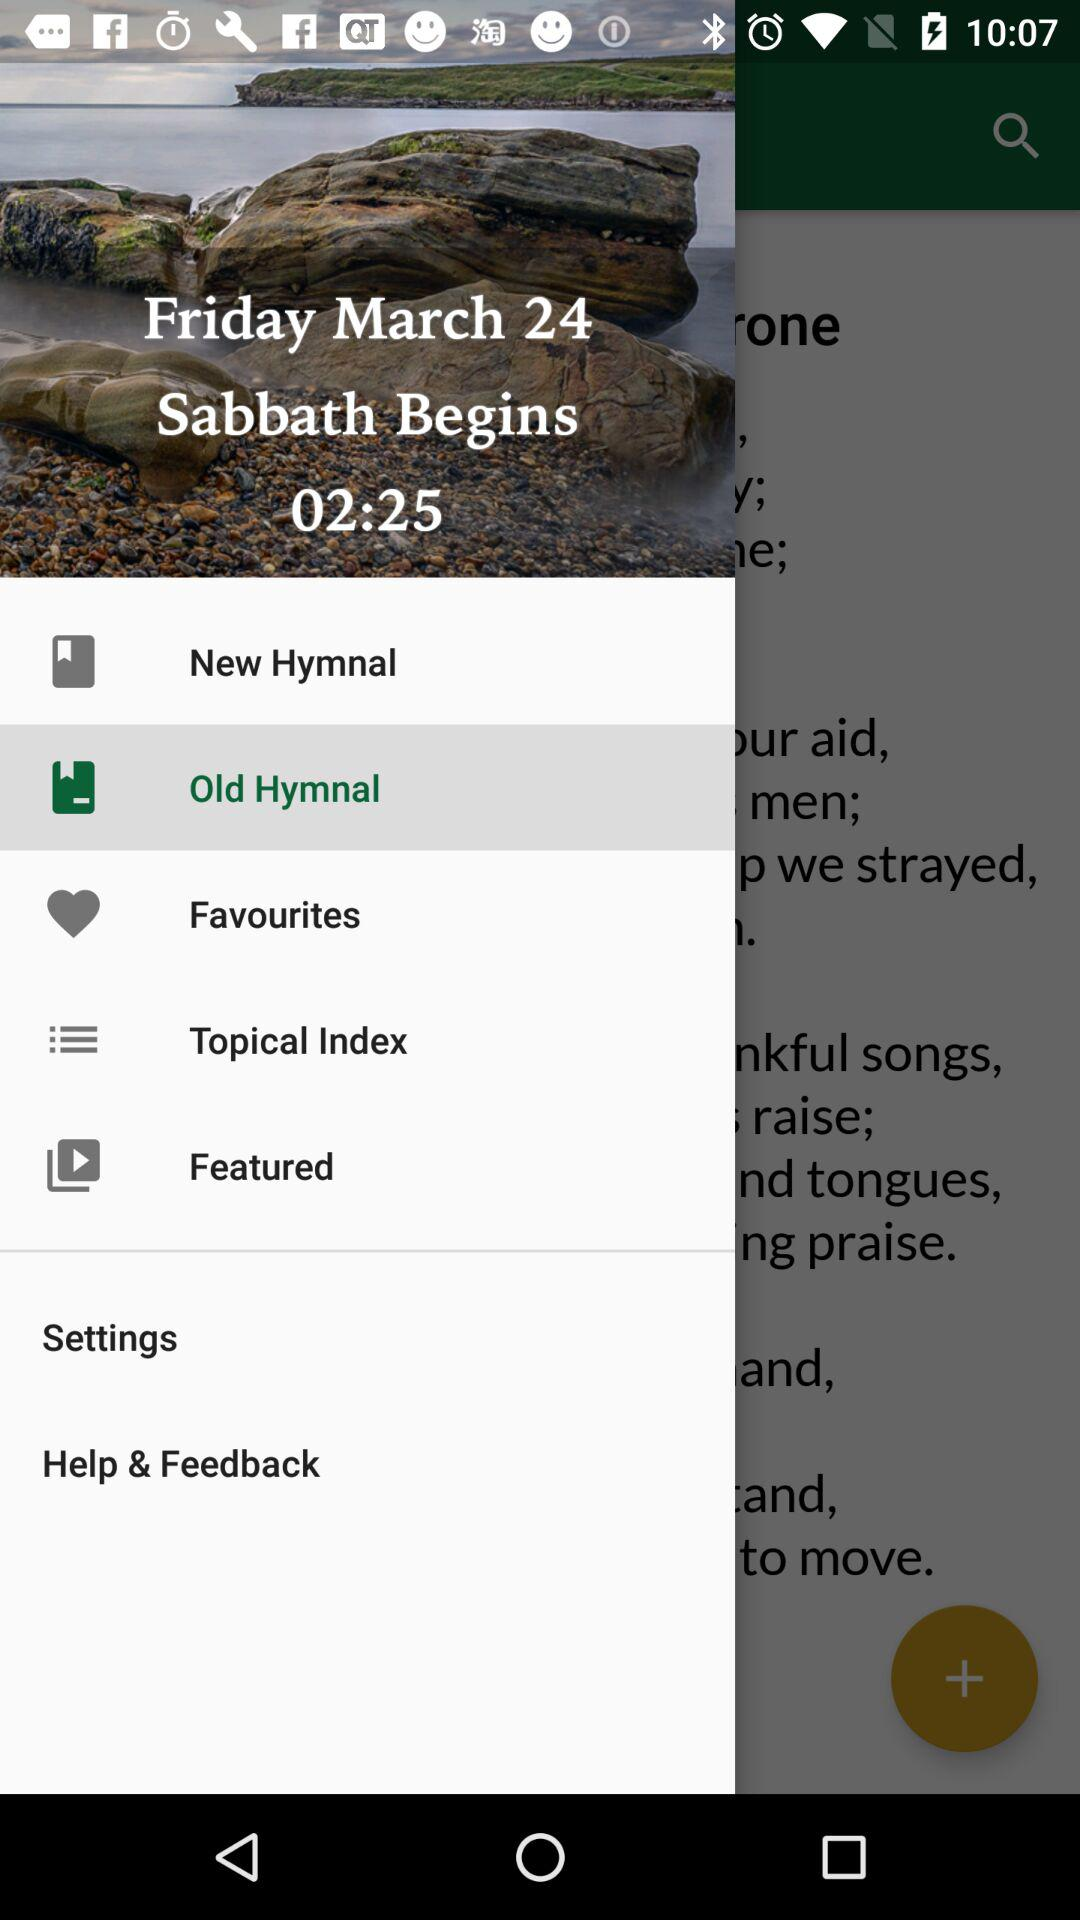Which item is selected? The selected item is "Old Hymnal". 